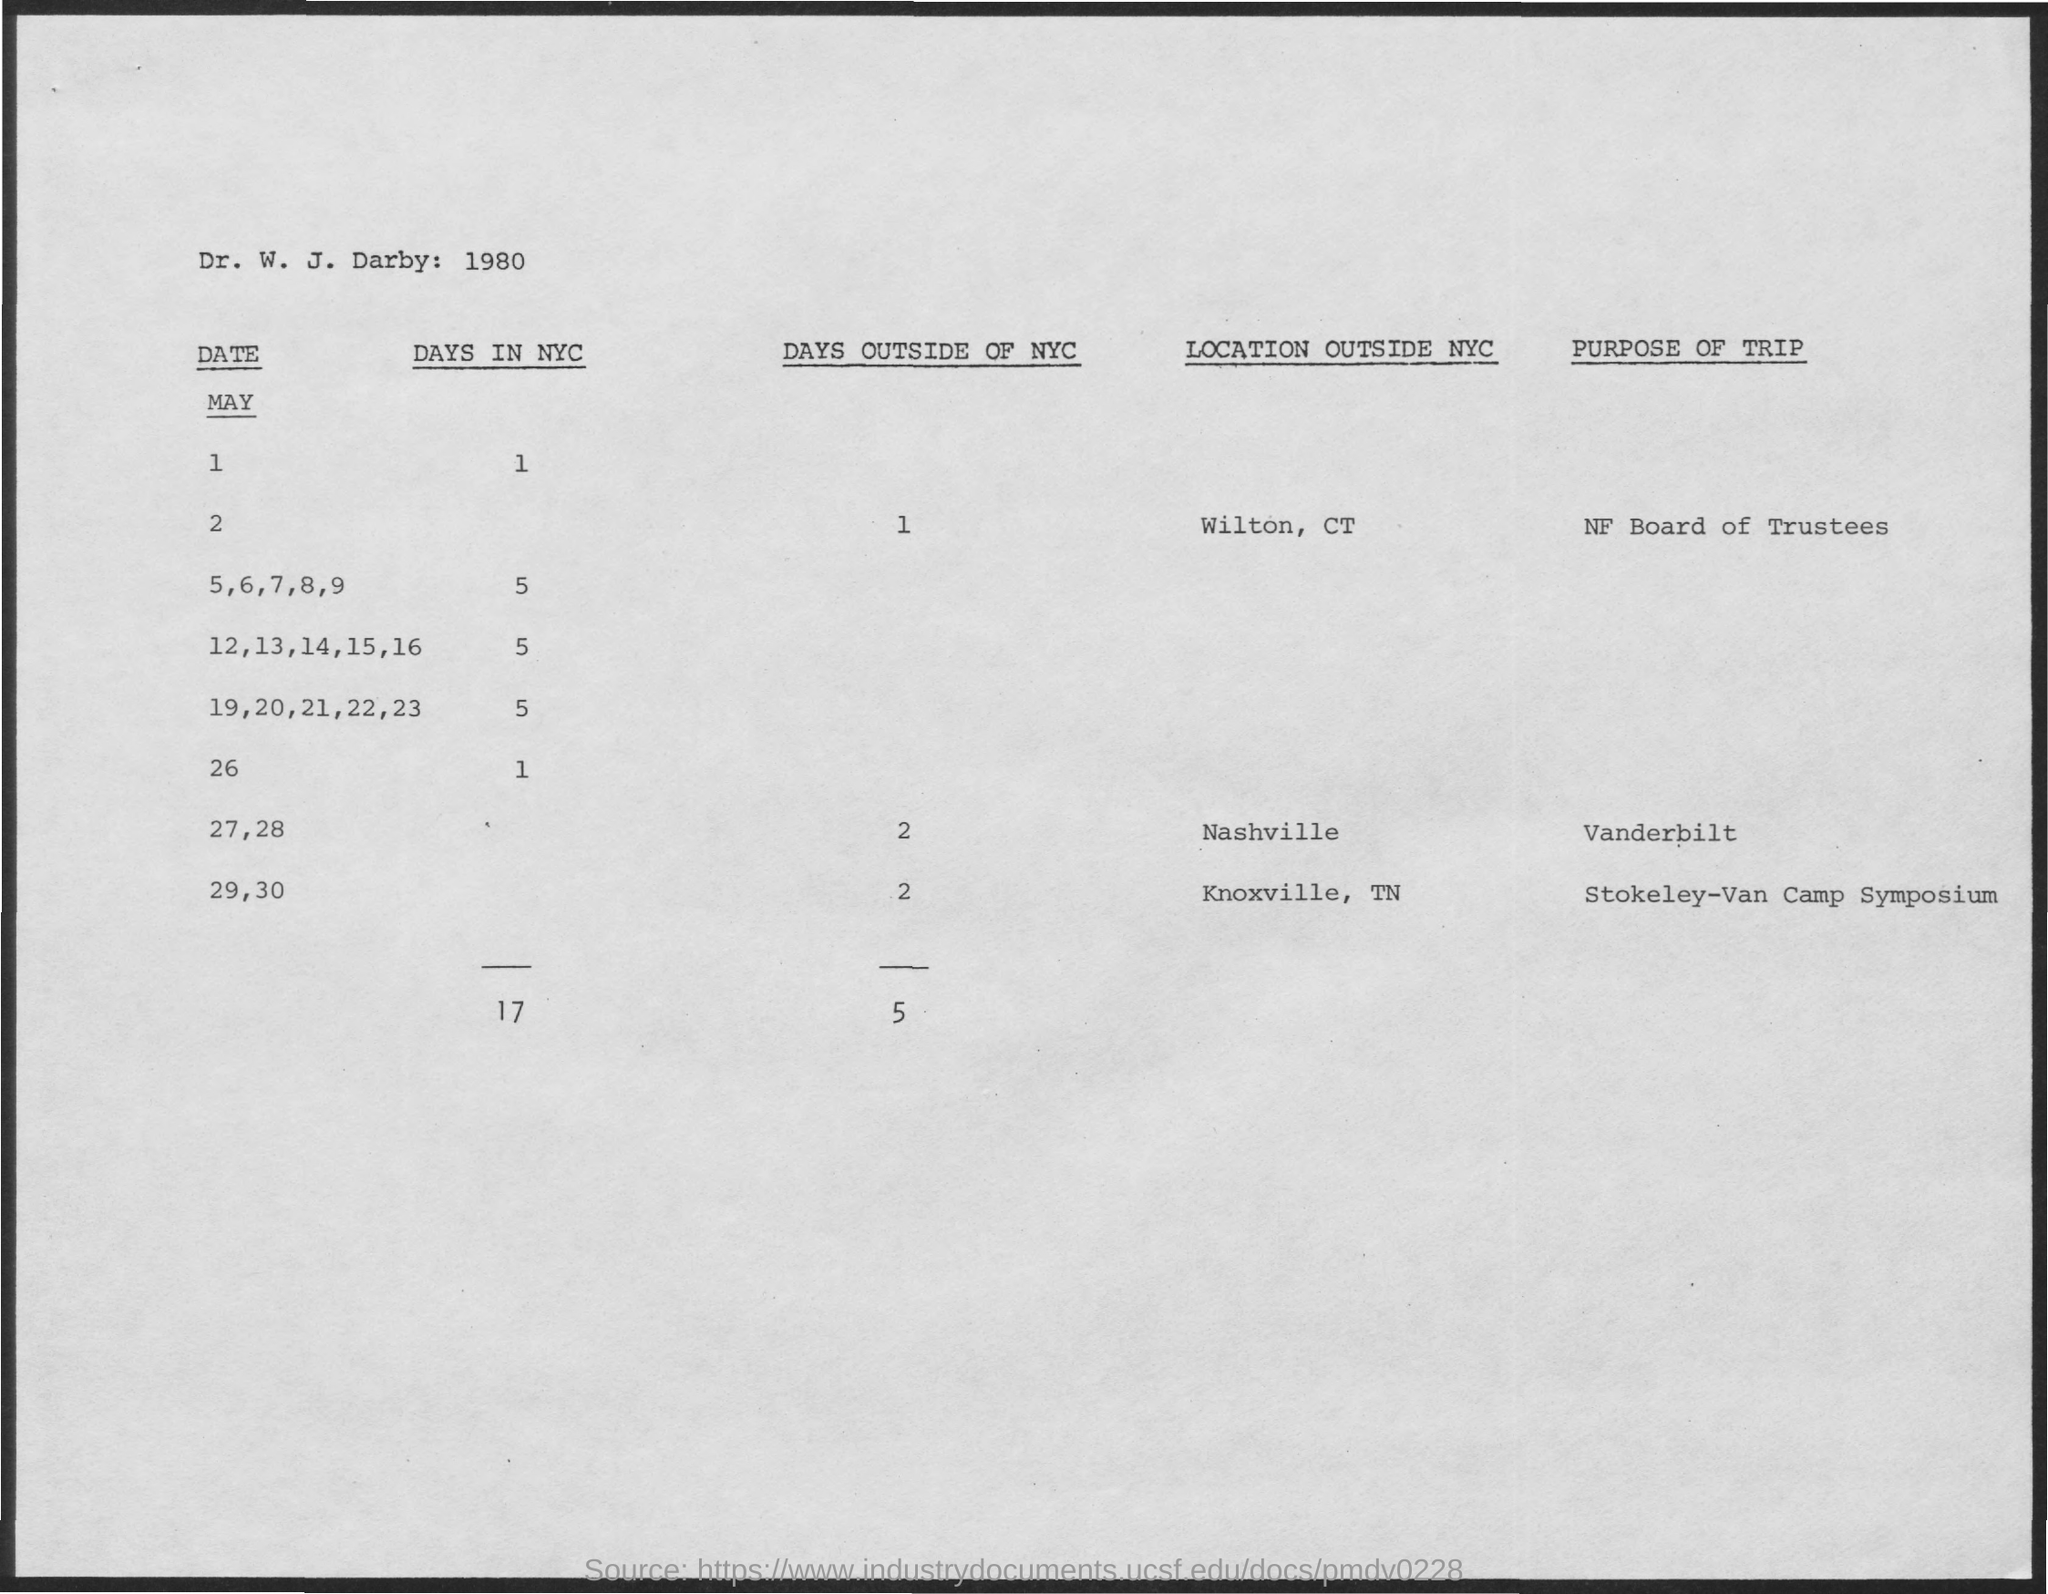What is the Purpose of Trip on May 2?
Your answer should be very brief. NF Board of Trustees. Number of days outside of NYC on May 27 and 28?
Your answer should be compact. 2. 